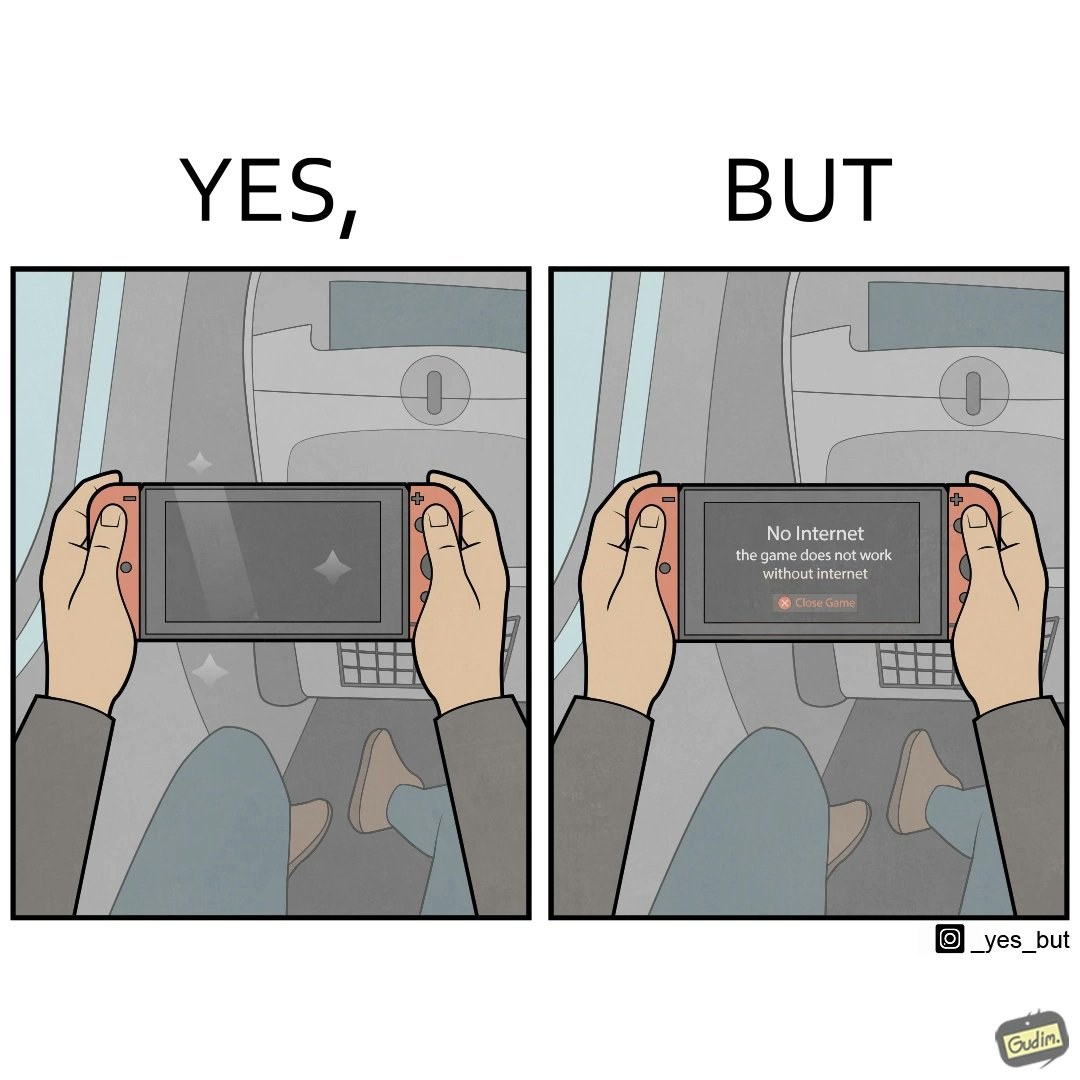Is there satirical content in this image? Yes, this image is satirical. 